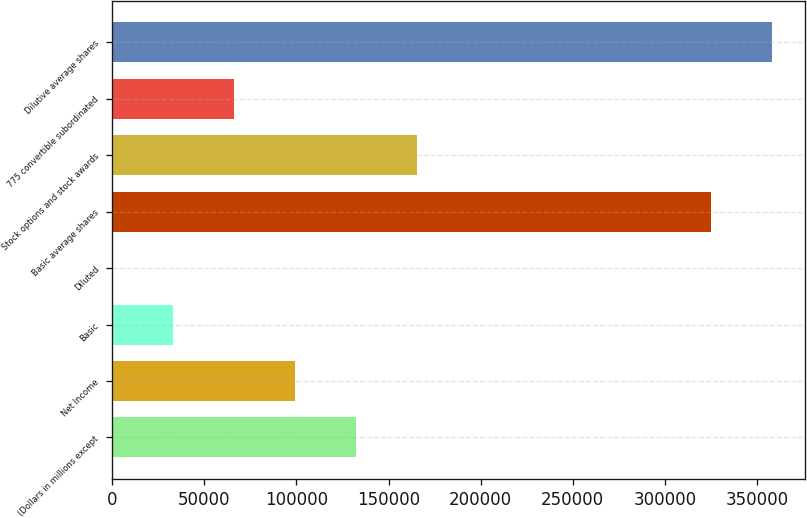Convert chart to OTSL. <chart><loc_0><loc_0><loc_500><loc_500><bar_chart><fcel>(Dollars in millions except<fcel>Net Income<fcel>Basic<fcel>Diluted<fcel>Basic average shares<fcel>Stock options and stock awards<fcel>775 convertible subordinated<fcel>Dilutive average shares<nl><fcel>132198<fcel>99148.9<fcel>33050.9<fcel>1.9<fcel>325030<fcel>165247<fcel>66099.9<fcel>358079<nl></chart> 